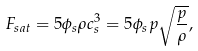<formula> <loc_0><loc_0><loc_500><loc_500>F _ { s a t } = 5 \phi _ { s } \rho c _ { s } ^ { 3 } = 5 \phi _ { s } p \sqrt { \frac { p } { \rho } } ,</formula> 